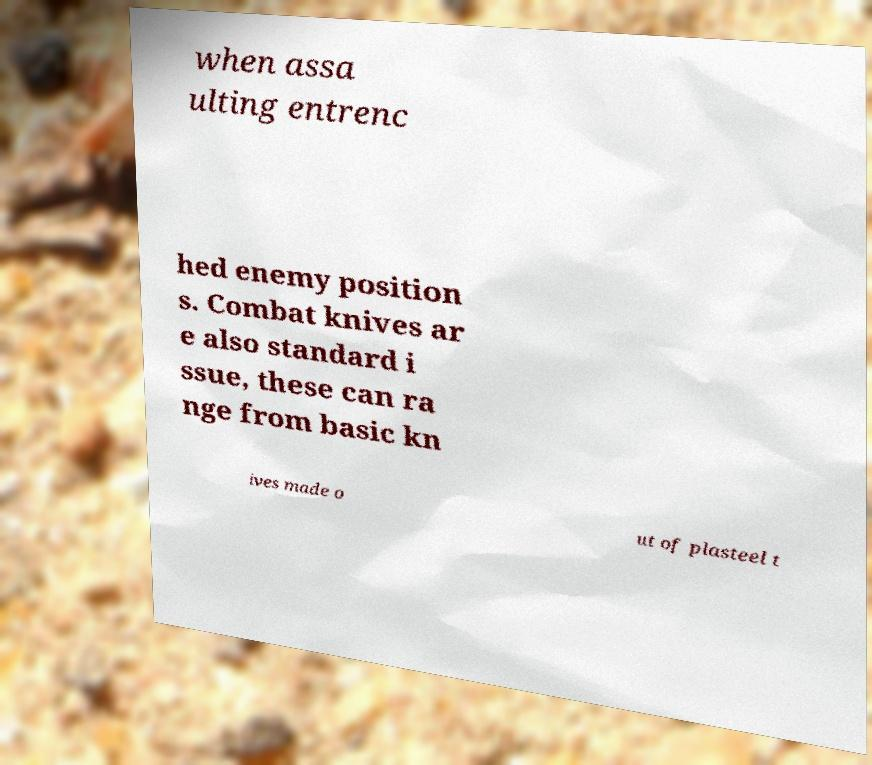I need the written content from this picture converted into text. Can you do that? when assa ulting entrenc hed enemy position s. Combat knives ar e also standard i ssue, these can ra nge from basic kn ives made o ut of plasteel t 